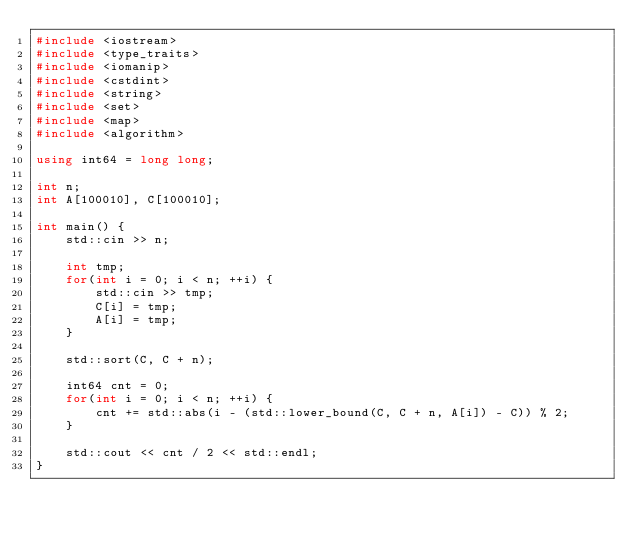<code> <loc_0><loc_0><loc_500><loc_500><_C++_>#include <iostream>
#include <type_traits>
#include <iomanip>
#include <cstdint>
#include <string>
#include <set>
#include <map>
#include <algorithm>

using int64 = long long;

int n;
int A[100010], C[100010];

int main() {
    std::cin >> n;
    
    int tmp;
    for(int i = 0; i < n; ++i) {
        std::cin >> tmp;
        C[i] = tmp;
        A[i] = tmp;
    }
    
    std::sort(C, C + n);
    
    int64 cnt = 0;
    for(int i = 0; i < n; ++i) {
        cnt += std::abs(i - (std::lower_bound(C, C + n, A[i]) - C)) % 2;
    }
    
    std::cout << cnt / 2 << std::endl;
}</code> 